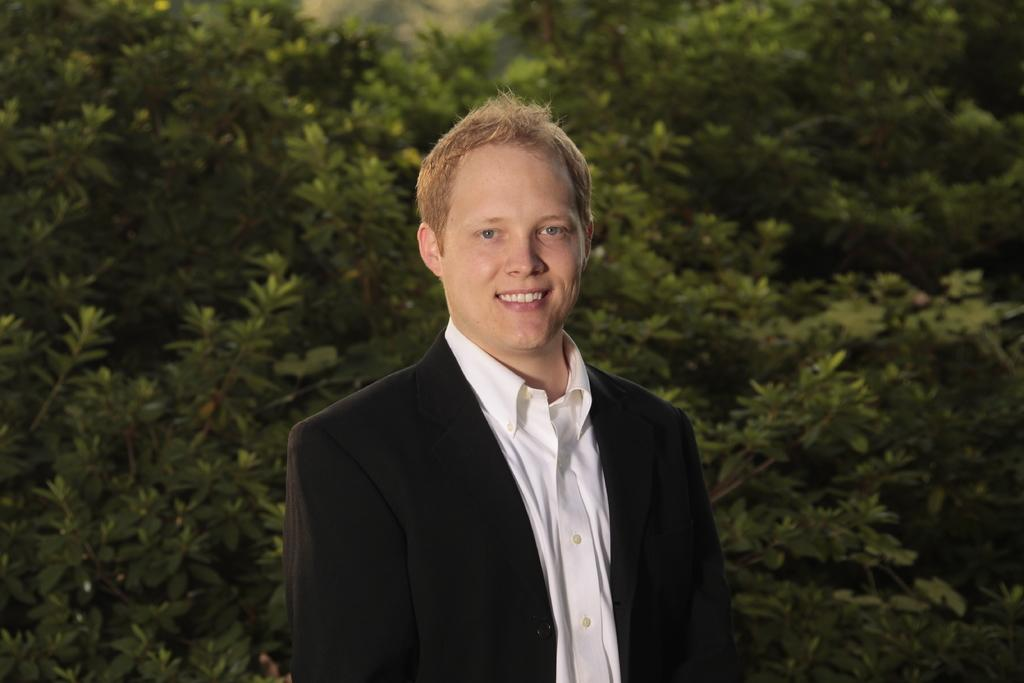What is present in the image? There is a person in the image. How is the person's facial expression in the image? The person is wearing a smile on his face. What type of natural environment can be seen in the image? There are trees visible in the image. What type of cable can be seen connecting the person to the trees in the image? There is no cable present in the image, and the person is not connected to the trees. Is the person in the image confined to a prison? There is no indication of a prison or confinement in the image; it simply shows a person smiling with trees in the background. 